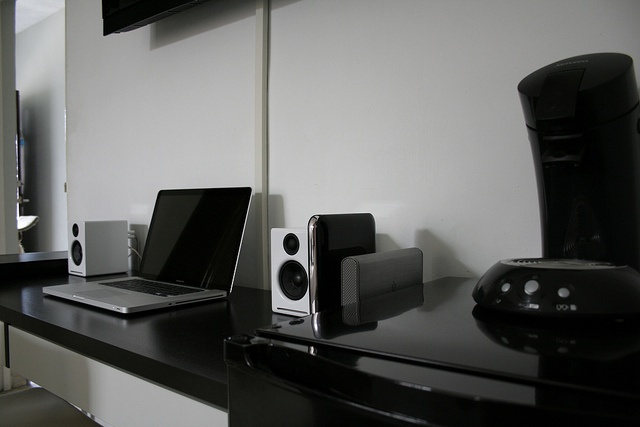Describe the objects in this image and their specific colors. I can see a laptop in gray, black, darkgray, and lightgray tones in this image. 